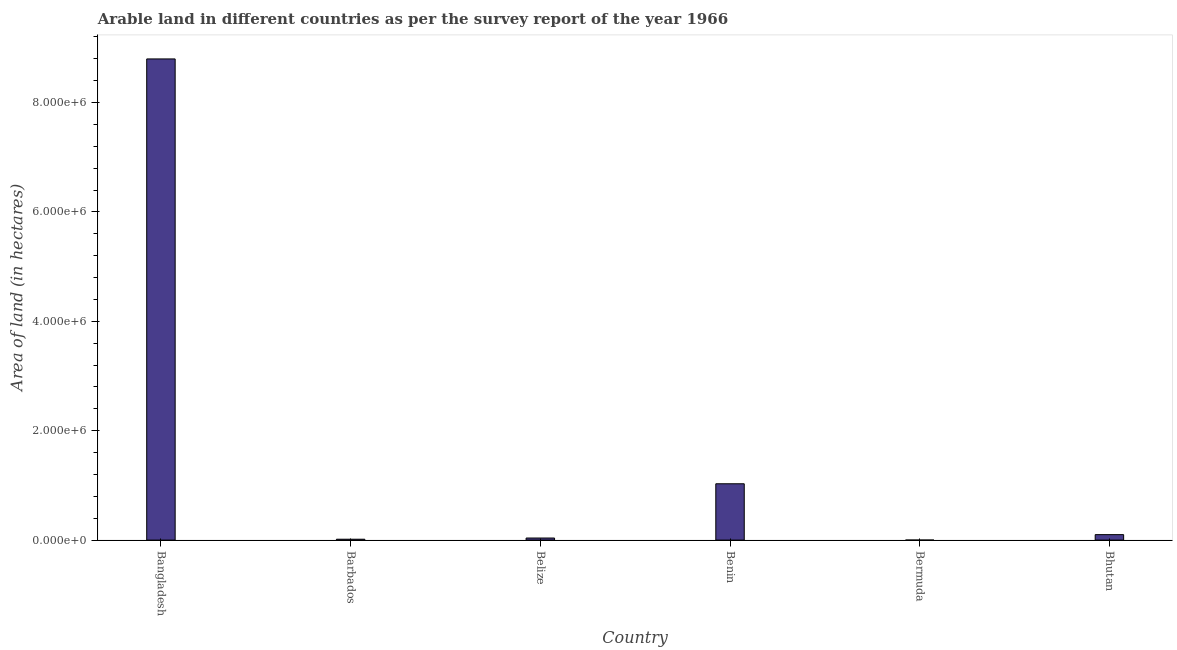Does the graph contain any zero values?
Ensure brevity in your answer.  No. What is the title of the graph?
Keep it short and to the point. Arable land in different countries as per the survey report of the year 1966. What is the label or title of the X-axis?
Your response must be concise. Country. What is the label or title of the Y-axis?
Ensure brevity in your answer.  Area of land (in hectares). What is the area of land in Benin?
Keep it short and to the point. 1.03e+06. Across all countries, what is the maximum area of land?
Your answer should be very brief. 8.80e+06. Across all countries, what is the minimum area of land?
Your answer should be compact. 400. In which country was the area of land maximum?
Offer a very short reply. Bangladesh. In which country was the area of land minimum?
Your answer should be compact. Bermuda. What is the sum of the area of land?
Give a very brief answer. 9.98e+06. What is the difference between the area of land in Barbados and Belize?
Provide a short and direct response. -2.20e+04. What is the average area of land per country?
Offer a terse response. 1.66e+06. What is the median area of land?
Ensure brevity in your answer.  6.90e+04. What is the ratio of the area of land in Barbados to that in Bhutan?
Make the answer very short. 0.16. Is the area of land in Bangladesh less than that in Bermuda?
Ensure brevity in your answer.  No. Is the difference between the area of land in Bangladesh and Belize greater than the difference between any two countries?
Offer a terse response. No. What is the difference between the highest and the second highest area of land?
Your answer should be very brief. 7.77e+06. What is the difference between the highest and the lowest area of land?
Make the answer very short. 8.80e+06. In how many countries, is the area of land greater than the average area of land taken over all countries?
Your response must be concise. 1. How many bars are there?
Provide a short and direct response. 6. Are the values on the major ticks of Y-axis written in scientific E-notation?
Keep it short and to the point. Yes. What is the Area of land (in hectares) in Bangladesh?
Ensure brevity in your answer.  8.80e+06. What is the Area of land (in hectares) of Barbados?
Provide a short and direct response. 1.60e+04. What is the Area of land (in hectares) in Belize?
Provide a short and direct response. 3.80e+04. What is the Area of land (in hectares) in Benin?
Give a very brief answer. 1.03e+06. What is the Area of land (in hectares) of Bhutan?
Provide a succinct answer. 1.00e+05. What is the difference between the Area of land (in hectares) in Bangladesh and Barbados?
Provide a succinct answer. 8.78e+06. What is the difference between the Area of land (in hectares) in Bangladesh and Belize?
Your answer should be compact. 8.76e+06. What is the difference between the Area of land (in hectares) in Bangladesh and Benin?
Make the answer very short. 7.77e+06. What is the difference between the Area of land (in hectares) in Bangladesh and Bermuda?
Make the answer very short. 8.80e+06. What is the difference between the Area of land (in hectares) in Bangladesh and Bhutan?
Offer a terse response. 8.70e+06. What is the difference between the Area of land (in hectares) in Barbados and Belize?
Offer a very short reply. -2.20e+04. What is the difference between the Area of land (in hectares) in Barbados and Benin?
Your answer should be compact. -1.01e+06. What is the difference between the Area of land (in hectares) in Barbados and Bermuda?
Provide a short and direct response. 1.56e+04. What is the difference between the Area of land (in hectares) in Barbados and Bhutan?
Ensure brevity in your answer.  -8.40e+04. What is the difference between the Area of land (in hectares) in Belize and Benin?
Offer a terse response. -9.92e+05. What is the difference between the Area of land (in hectares) in Belize and Bermuda?
Provide a succinct answer. 3.76e+04. What is the difference between the Area of land (in hectares) in Belize and Bhutan?
Your answer should be compact. -6.20e+04. What is the difference between the Area of land (in hectares) in Benin and Bermuda?
Ensure brevity in your answer.  1.03e+06. What is the difference between the Area of land (in hectares) in Benin and Bhutan?
Offer a very short reply. 9.30e+05. What is the difference between the Area of land (in hectares) in Bermuda and Bhutan?
Keep it short and to the point. -9.96e+04. What is the ratio of the Area of land (in hectares) in Bangladesh to that in Barbados?
Your answer should be very brief. 549.88. What is the ratio of the Area of land (in hectares) in Bangladesh to that in Belize?
Make the answer very short. 231.53. What is the ratio of the Area of land (in hectares) in Bangladesh to that in Benin?
Offer a terse response. 8.54. What is the ratio of the Area of land (in hectares) in Bangladesh to that in Bermuda?
Keep it short and to the point. 2.20e+04. What is the ratio of the Area of land (in hectares) in Bangladesh to that in Bhutan?
Make the answer very short. 87.98. What is the ratio of the Area of land (in hectares) in Barbados to that in Belize?
Your answer should be very brief. 0.42. What is the ratio of the Area of land (in hectares) in Barbados to that in Benin?
Your answer should be very brief. 0.02. What is the ratio of the Area of land (in hectares) in Barbados to that in Bermuda?
Ensure brevity in your answer.  40. What is the ratio of the Area of land (in hectares) in Barbados to that in Bhutan?
Offer a very short reply. 0.16. What is the ratio of the Area of land (in hectares) in Belize to that in Benin?
Your answer should be compact. 0.04. What is the ratio of the Area of land (in hectares) in Belize to that in Bhutan?
Your answer should be very brief. 0.38. What is the ratio of the Area of land (in hectares) in Benin to that in Bermuda?
Keep it short and to the point. 2575. What is the ratio of the Area of land (in hectares) in Benin to that in Bhutan?
Offer a terse response. 10.3. What is the ratio of the Area of land (in hectares) in Bermuda to that in Bhutan?
Give a very brief answer. 0. 